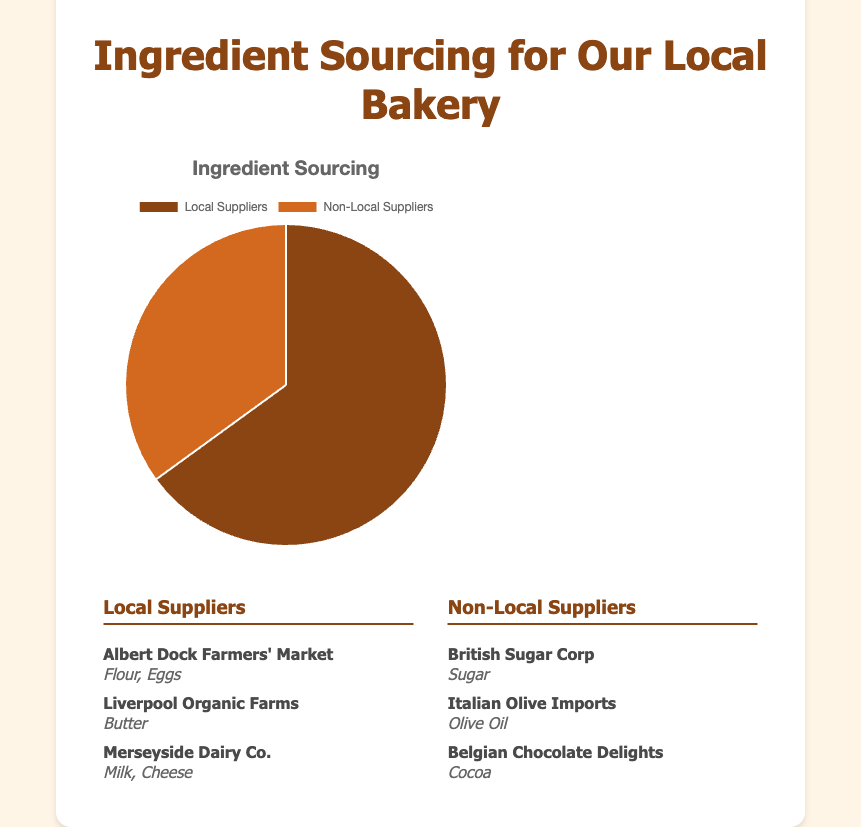How much of the ingredients are sourced from local suppliers? The pie chart shows that local suppliers account for 65% of the ingredients.
Answer: 65% What percentage of ingredients comes from non-local suppliers? The pie chart shows that non-local suppliers account for 35% of the ingredients.
Answer: 35% Which type of supplier provides the majority of ingredients? The pie chart indicates that local suppliers, with 65% of the ingredients, provide the majority compared to non-local suppliers, who provide 35%.
Answer: Local suppliers What is the ratio of ingredients sourced from local suppliers to non-local suppliers? The percentage of ingredients from local suppliers is 65%, and from non-local suppliers is 35%. Therefore, the ratio can be calculated as 65:35 or simplified to 13:7.
Answer: 13:7 How many more ingredients are sourced from local suppliers than non-local suppliers? The percentage of ingredients from local suppliers (65%) minus the percentage from non-local suppliers (35%) gives the difference. 65 - 35 = 30%.
Answer: 30% What color represents the local suppliers on the pie chart? The section representing local suppliers is shown in a brown color.
Answer: Brown If you merged the percentage of ingredients from Italian Olive Imports and Belgian Chocolate Delights, would they still be less than the local suppliers' percentage? Italian Olive Imports and Belgian Chocolate Delights are part of the 35% for non-local suppliers. Since 35% is already less than the 65% for local suppliers, combining two non-local suppliers won't exceed the local suppliers' percentage.
Answer: Yes List three suppliers that provide ingredients locally. According to the supplier list under the local suppliers section, the three suppliers are Albert Dock Farmers' Market, Liverpool Organic Farms, and Merseyside Dairy Co.
Answer: Albert Dock Farmers' Market, Liverpool Organic Farms, Merseyside Dairy Co Identify which non-local supplier is responsible for providing sugar. From the non-local suppliers’ list, British Sugar Corp is the supplier providing sugar.
Answer: British Sugar Corp 